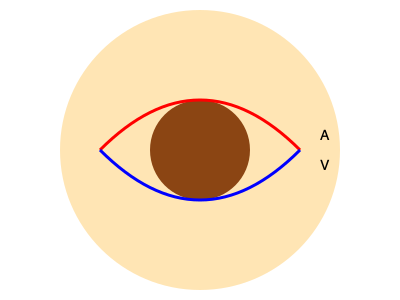In fundus photography analysis for diabetic retinopathy, what is the significance of the arteriovenous (A/V) ratio, and how does it change in severe cases of diabetic retinopathy? 1. The A/V ratio is a measure used in retinal blood vessel analysis, comparing the diameter of arteries to veins.

2. In a healthy retina, the A/V ratio is typically around 2:3 or 0.67, meaning arteries are about two-thirds the width of veins.

3. In diabetic retinopathy:
   a) Hyperglycemia causes damage to blood vessel walls.
   b) This leads to increased vascular permeability and potential microaneurysms.

4. As diabetic retinopathy progresses:
   a) Veins tend to dilate and become more tortuous.
   b) Arteries may narrow due to endothelial dysfunction and atherosclerosis.

5. These changes result in a decreased A/V ratio:
   a) Severe cases may show ratios of 1:2 (0.5) or lower.
   b) This indicates significant vascular remodeling and potential ischemia.

6. Implications of a reduced A/V ratio:
   a) Increased risk of retinal ischemia and neovascularization.
   b) Higher likelihood of vision-threatening complications.

7. Regular monitoring of the A/V ratio through fundus photography can help:
   a) Track disease progression.
   b) Guide treatment decisions.
   c) Assess the effectiveness of interventions.
Answer: The A/V ratio decreases in severe diabetic retinopathy, potentially falling to 1:2 (0.5) or lower, indicating significant vascular remodeling and increased risk of complications. 